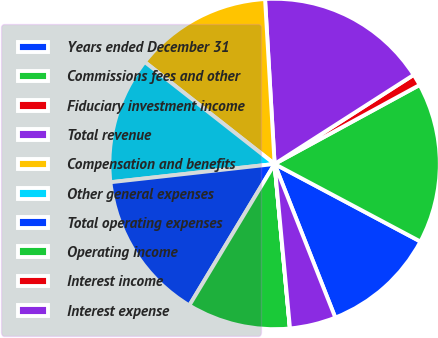Convert chart. <chart><loc_0><loc_0><loc_500><loc_500><pie_chart><fcel>Years ended December 31<fcel>Commissions fees and other<fcel>Fiduciary investment income<fcel>Total revenue<fcel>Compensation and benefits<fcel>Other general expenses<fcel>Total operating expenses<fcel>Operating income<fcel>Interest income<fcel>Interest expense<nl><fcel>11.23%<fcel>15.72%<fcel>1.13%<fcel>16.85%<fcel>13.48%<fcel>12.36%<fcel>14.6%<fcel>10.11%<fcel>0.01%<fcel>4.5%<nl></chart> 